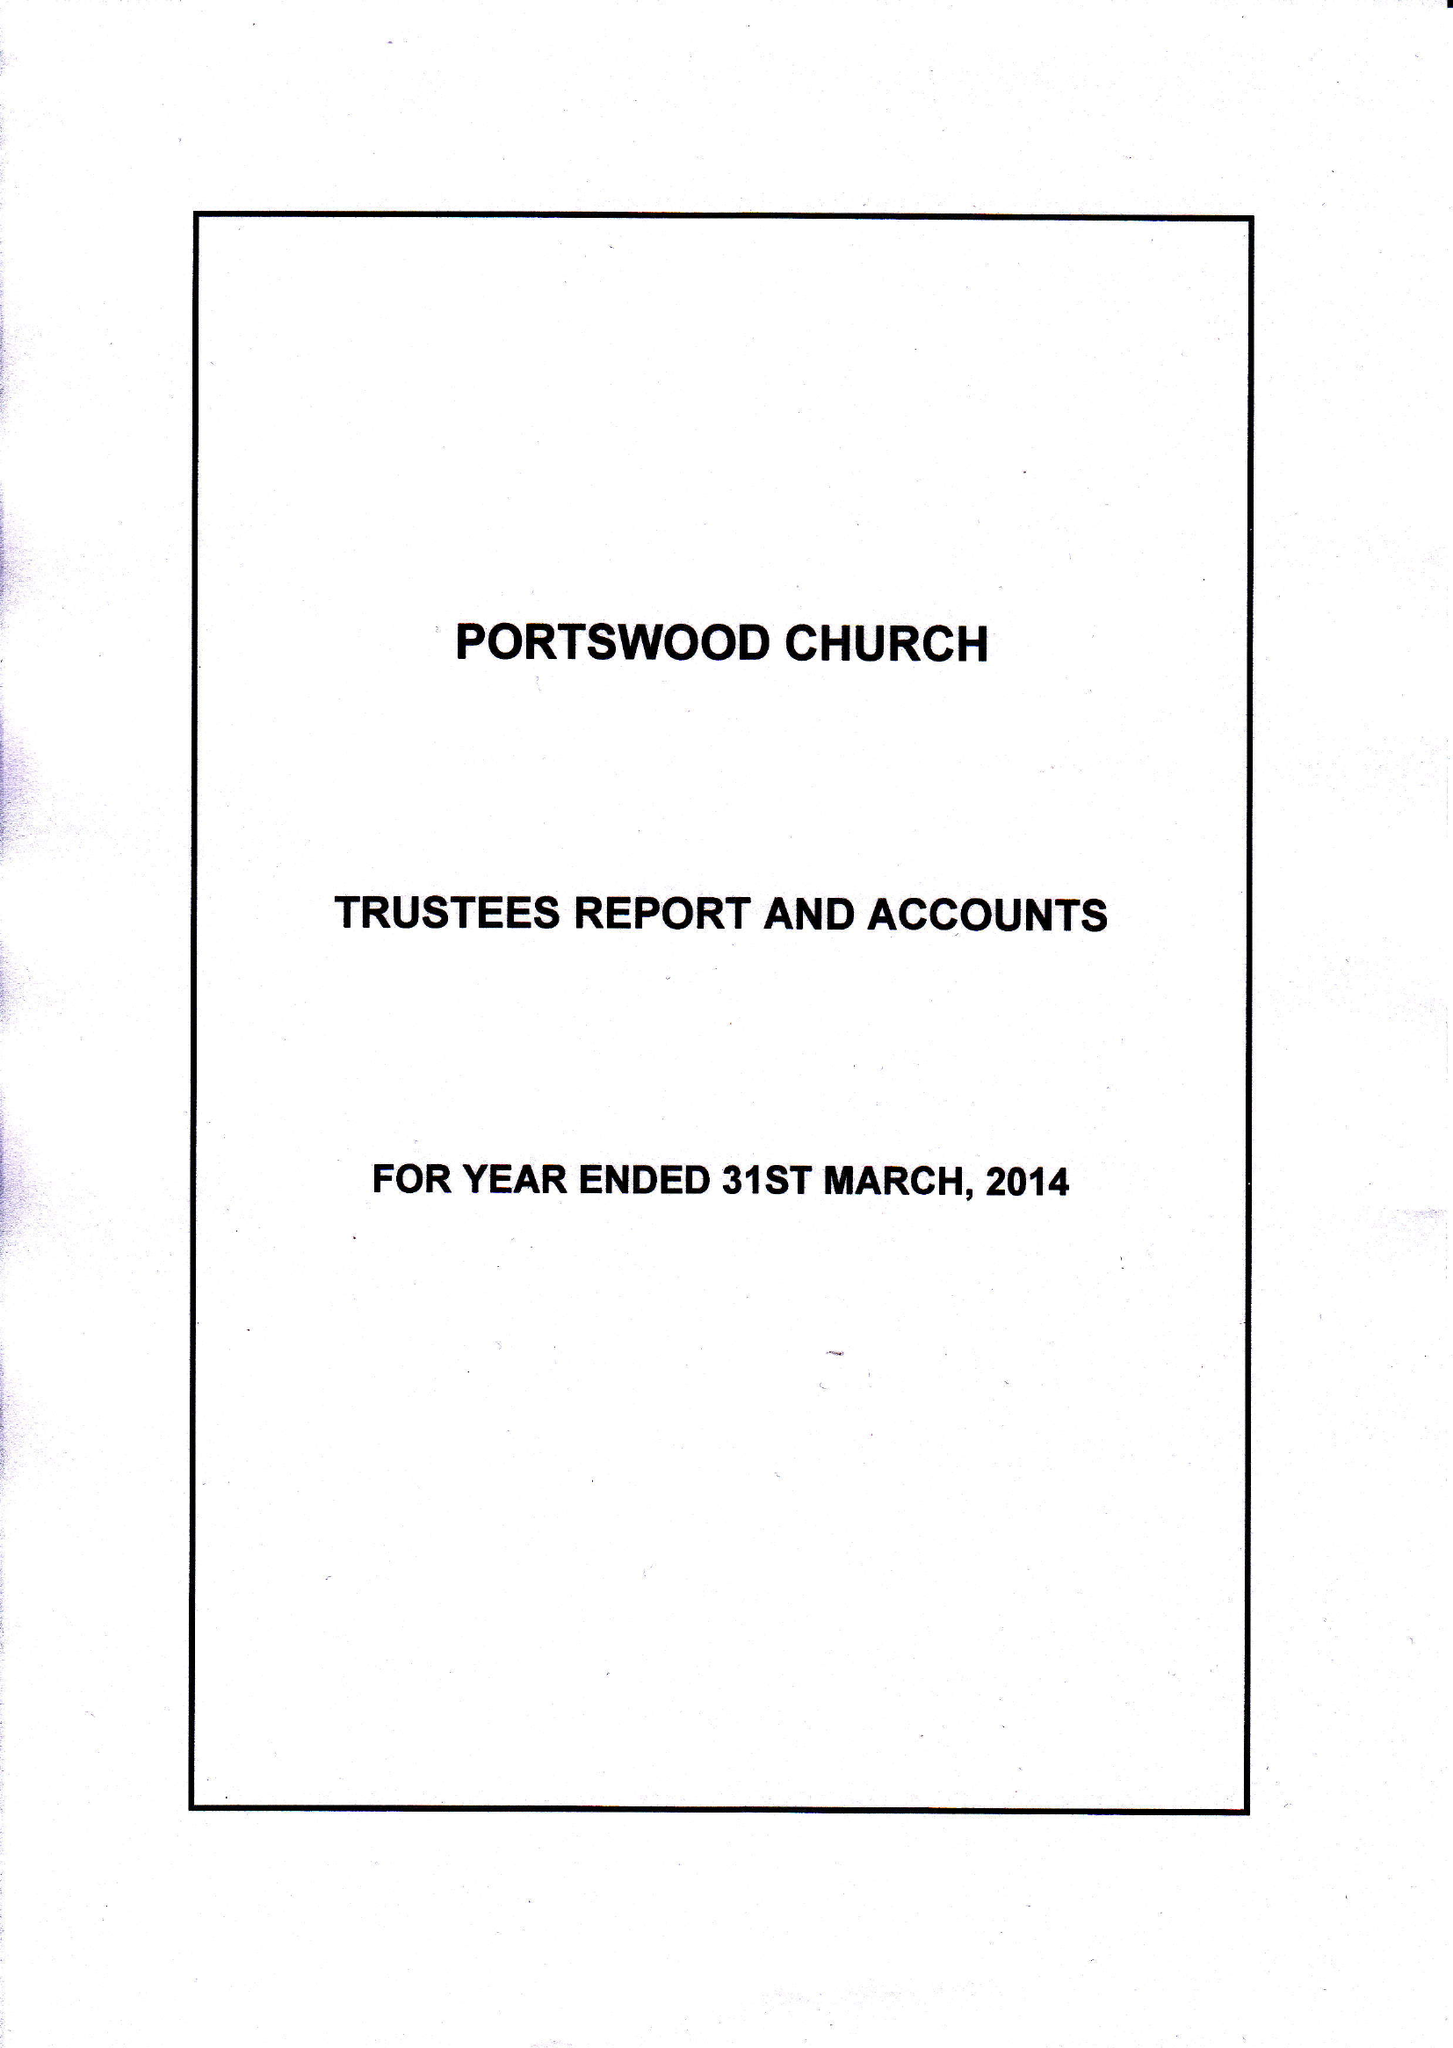What is the value for the address__street_line?
Answer the question using a single word or phrase. PORTSWOOD ROAD 